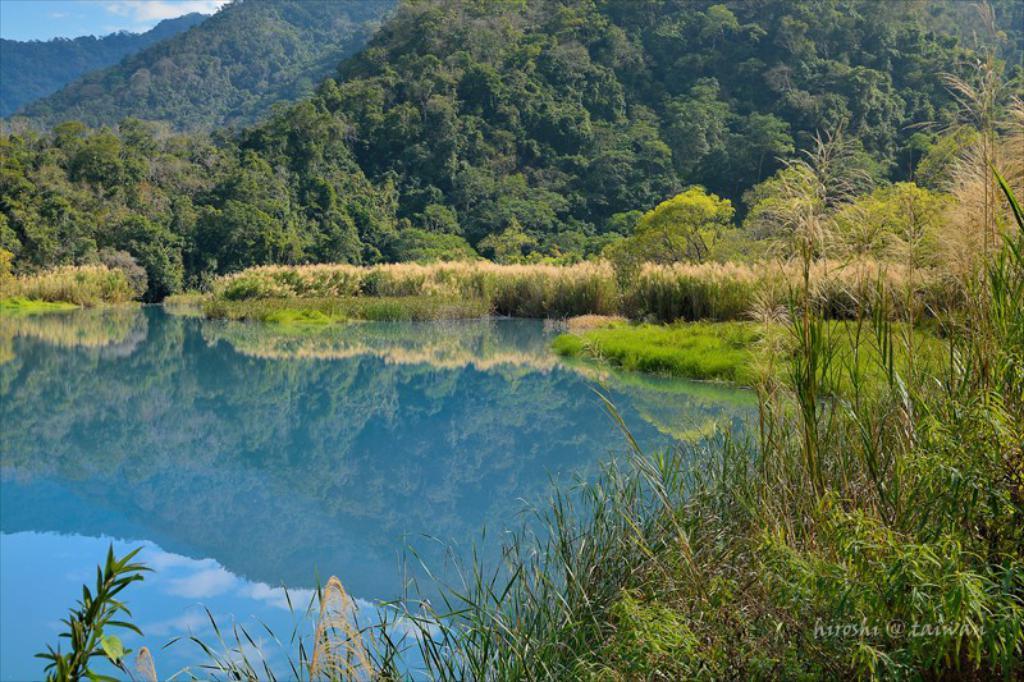Can you describe this image briefly? This is an outside view. On the left side there is a sea and on the right side, I can see some plants and grass in green color. In the background there are some trees and hills. On the left top of the image I can see the sky and clouds. 